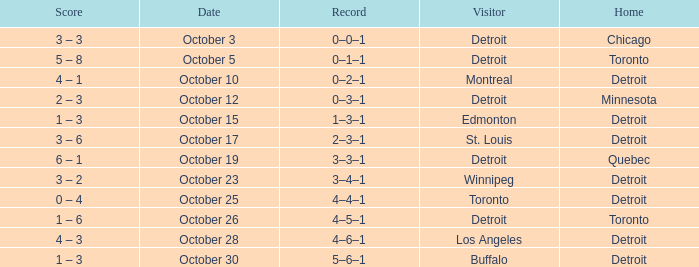Name the home with toronto visiting Detroit. 